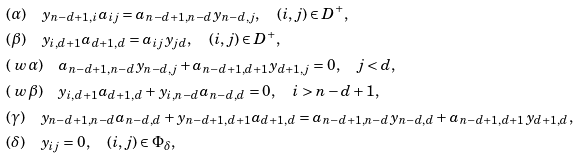<formula> <loc_0><loc_0><loc_500><loc_500>& ( \alpha ) \quad y _ { n - d + 1 , i } a _ { i j } = a _ { n - d + 1 , n - d } y _ { n - d , j } , \quad ( i , j ) \in D ^ { + } , \\ & ( \beta ) \quad y _ { i , d + 1 } a _ { d + 1 , d } = a _ { i j } y _ { j d } , \quad ( i , j ) \in D ^ { + } , \\ & ( \ w \alpha ) \quad a _ { n - d + 1 , n - d } y _ { n - d , j } + a _ { n - d + 1 , d + 1 } y _ { d + 1 , j } = 0 , \quad j < d , \\ & ( \ w \beta ) \quad y _ { i , d + 1 } a _ { d + 1 , d } + y _ { i , n - d } a _ { n - d , d } = 0 , \quad i > n - d + 1 , \\ & ( \gamma ) \quad y _ { n - d + 1 , n - d } a _ { n - d , d } + y _ { n - d + 1 , d + 1 } a _ { d + 1 , d } = a _ { n - d + 1 , n - d } y _ { n - d , d } + a _ { n - d + 1 , d + 1 } y _ { d + 1 , d } , \\ & ( \delta ) \quad y _ { i j } = 0 , \quad ( i , j ) \in \Phi _ { \delta } , \\</formula> 